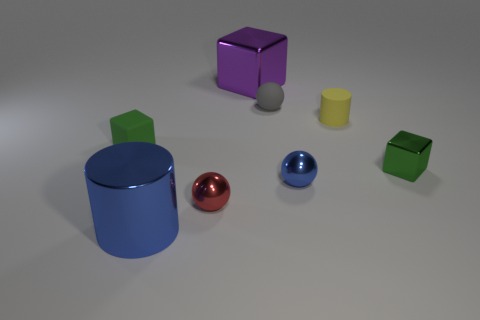Subtract 1 balls. How many balls are left? 2 Add 1 large blocks. How many objects exist? 9 Subtract all cubes. How many objects are left? 5 Add 1 gray rubber spheres. How many gray rubber spheres exist? 2 Subtract 0 green spheres. How many objects are left? 8 Subtract all blue metallic things. Subtract all rubber cylinders. How many objects are left? 5 Add 6 purple objects. How many purple objects are left? 7 